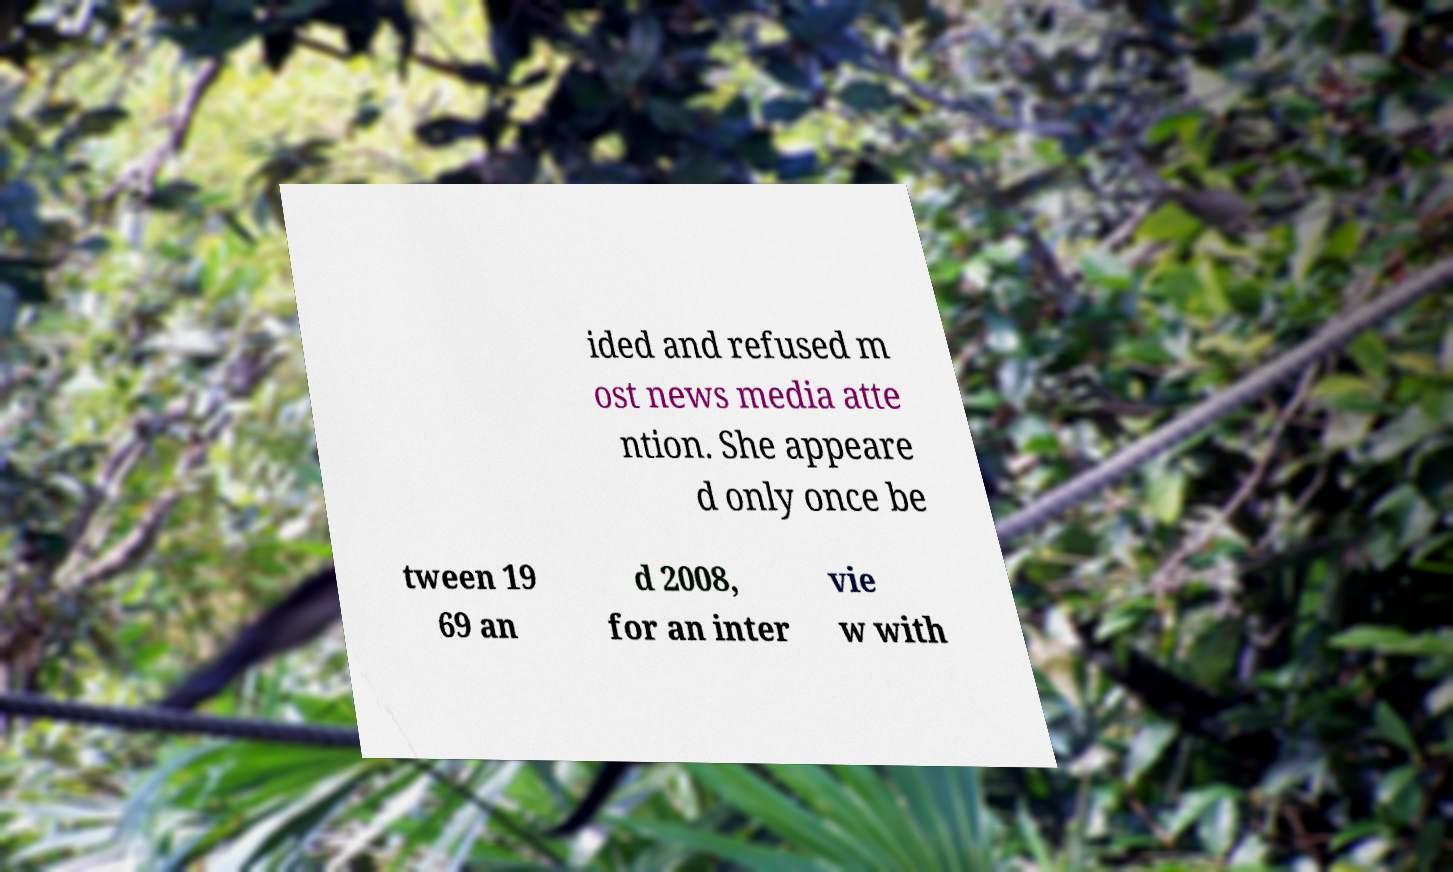What messages or text are displayed in this image? I need them in a readable, typed format. ided and refused m ost news media atte ntion. She appeare d only once be tween 19 69 an d 2008, for an inter vie w with 